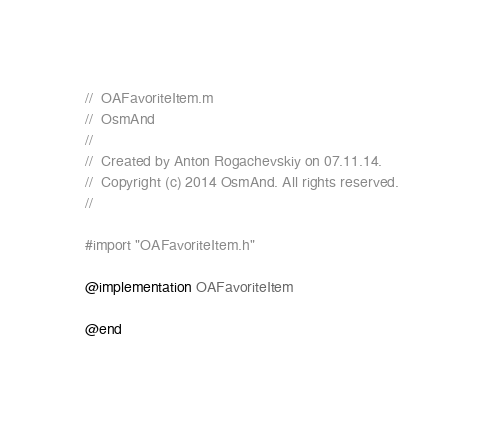Convert code to text. <code><loc_0><loc_0><loc_500><loc_500><_ObjectiveC_>//  OAFavoriteItem.m
//  OsmAnd
//
//  Created by Anton Rogachevskiy on 07.11.14.
//  Copyright (c) 2014 OsmAnd. All rights reserved.
//

#import "OAFavoriteItem.h"

@implementation OAFavoriteItem

@end
</code> 